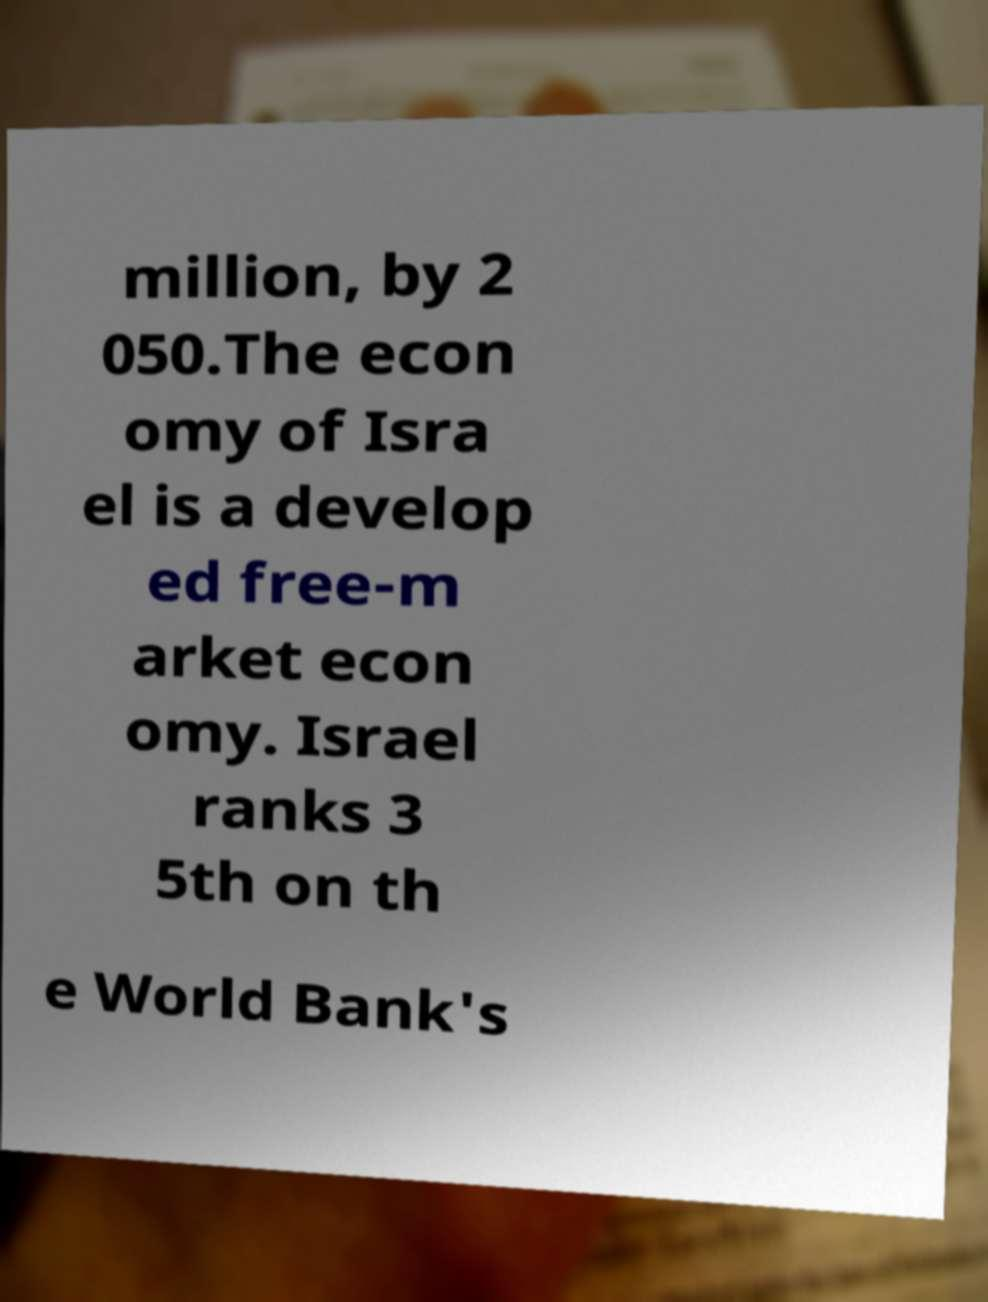For documentation purposes, I need the text within this image transcribed. Could you provide that? million, by 2 050.The econ omy of Isra el is a develop ed free-m arket econ omy. Israel ranks 3 5th on th e World Bank's 